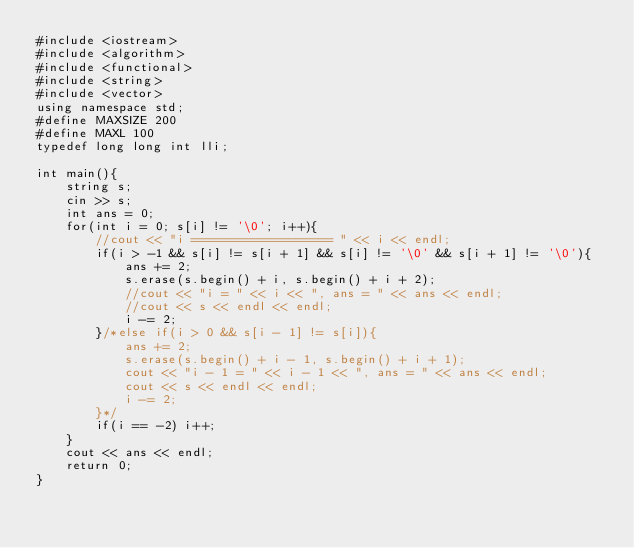Convert code to text. <code><loc_0><loc_0><loc_500><loc_500><_C++_>#include <iostream>
#include <algorithm>
#include <functional>
#include <string>
#include <vector>
using namespace std;
#define MAXSIZE 200
#define MAXL 100
typedef long long int lli;

int main(){
    string s;
    cin >> s;
    int ans = 0;
    for(int i = 0; s[i] != '\0'; i++){
        //cout << "i =================== " << i << endl;
        if(i > -1 && s[i] != s[i + 1] && s[i] != '\0' && s[i + 1] != '\0'){
            ans += 2;
            s.erase(s.begin() + i, s.begin() + i + 2);
            //cout << "i = " << i << ", ans = " << ans << endl;
            //cout << s << endl << endl;
            i -= 2;
        }/*else if(i > 0 && s[i - 1] != s[i]){
            ans += 2;
            s.erase(s.begin() + i - 1, s.begin() + i + 1);
            cout << "i - 1 = " << i - 1 << ", ans = " << ans << endl;
            cout << s << endl << endl;
            i -= 2;
        }*/
        if(i == -2) i++;
    }
    cout << ans << endl;
    return 0;
}</code> 